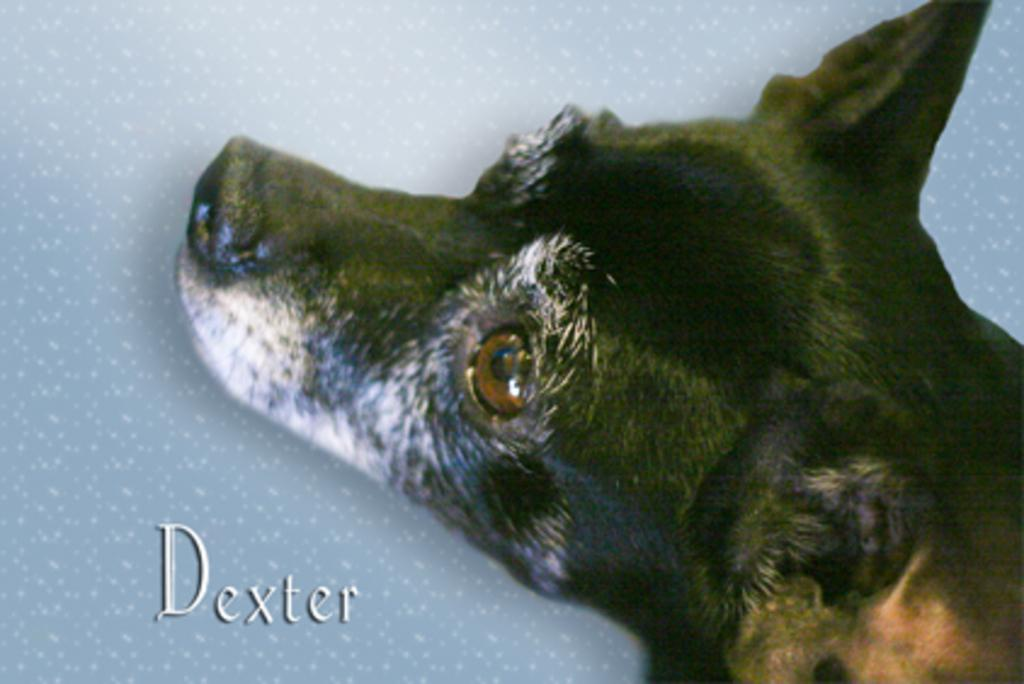What type of creature is present in the image? There is an animal in the image. Can you describe the setting or environment in the image? There is a background in the image. Is there any written information in the image? Yes, there is some text in the image. What is the weather like in the image? The provided facts do not mention any information about the weather, so it cannot be determined from the image. 